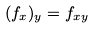<formula> <loc_0><loc_0><loc_500><loc_500>( f _ { x } ) _ { y } = f _ { x y }</formula> 